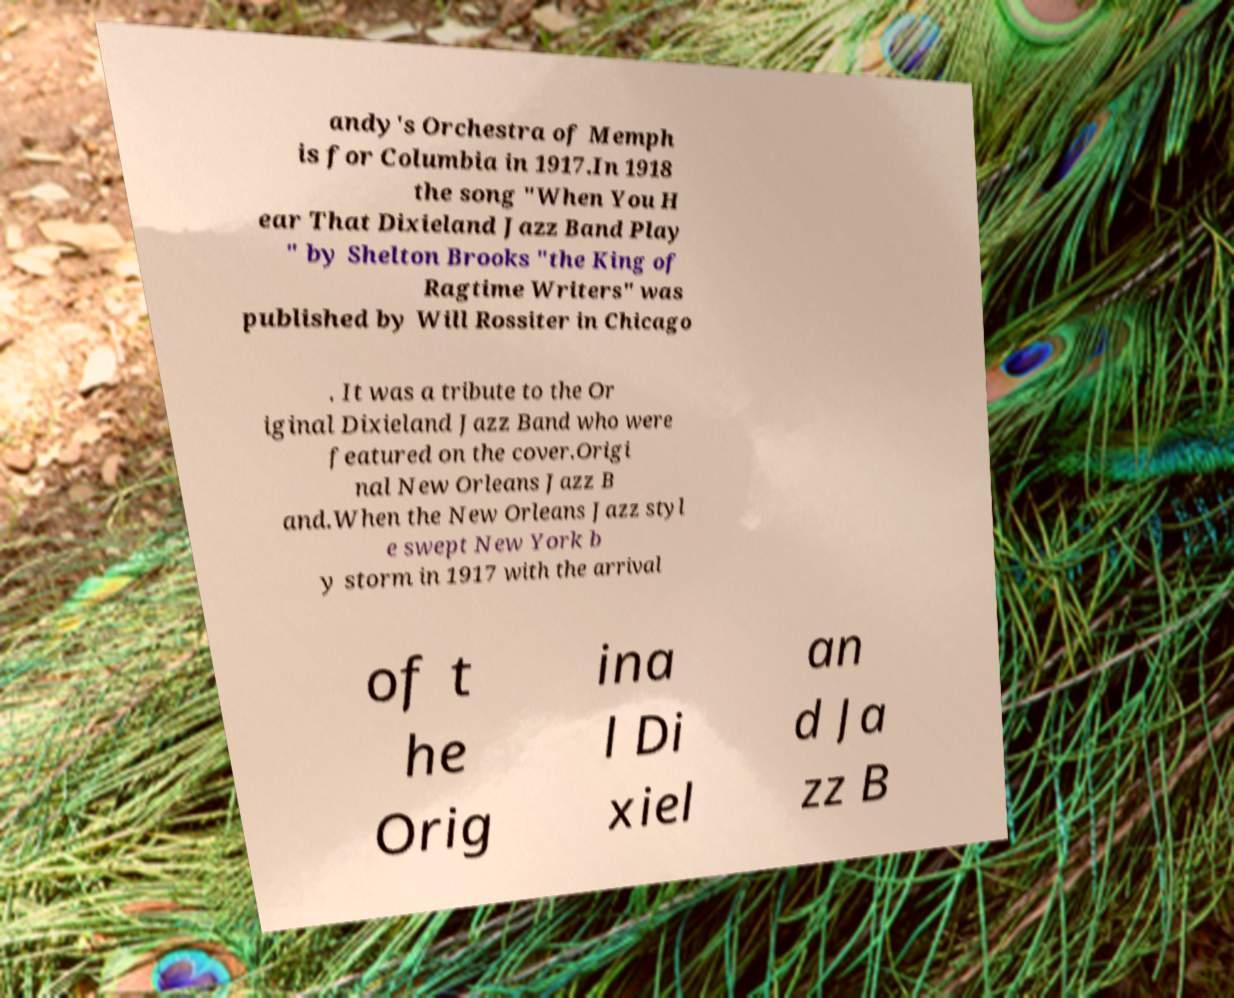Please read and relay the text visible in this image. What does it say? andy's Orchestra of Memph is for Columbia in 1917.In 1918 the song "When You H ear That Dixieland Jazz Band Play " by Shelton Brooks "the King of Ragtime Writers" was published by Will Rossiter in Chicago . It was a tribute to the Or iginal Dixieland Jazz Band who were featured on the cover.Origi nal New Orleans Jazz B and.When the New Orleans Jazz styl e swept New York b y storm in 1917 with the arrival of t he Orig ina l Di xiel an d Ja zz B 